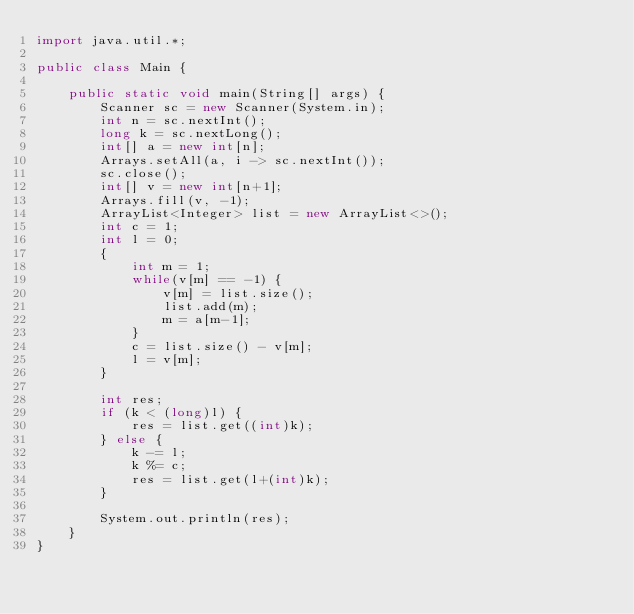Convert code to text. <code><loc_0><loc_0><loc_500><loc_500><_Java_>import java.util.*;

public class Main {

    public static void main(String[] args) {
        Scanner sc = new Scanner(System.in);
        int n = sc.nextInt();
        long k = sc.nextLong();
        int[] a = new int[n];
        Arrays.setAll(a, i -> sc.nextInt());
        sc.close();
        int[] v = new int[n+1];
        Arrays.fill(v, -1);
        ArrayList<Integer> list = new ArrayList<>();
        int c = 1;
        int l = 0;
        {
            int m = 1;
            while(v[m] == -1) {
                v[m] = list.size();
                list.add(m);
                m = a[m-1];
            }
            c = list.size() - v[m];
            l = v[m];
        }
        
        int res;
        if (k < (long)l) {
            res = list.get((int)k);
        } else {
            k -= l;
            k %= c;
            res = list.get(l+(int)k);
        }
        
        System.out.println(res);
    }
}</code> 